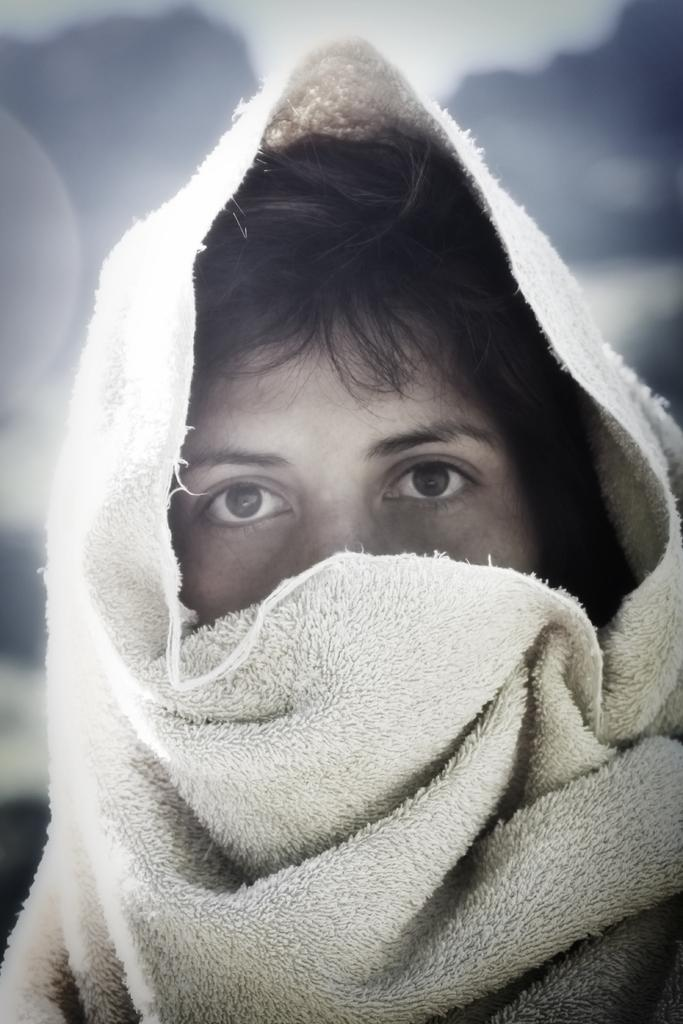What is the main subject of the image? There is a person in the image. What is the person wearing on their head? The person is wearing a cloth on their head. What color is the cloth? The cloth is white in color. How would you describe the background of the image? The background of the image is blurred. How many dogs are sitting on the pan in the image? There are no dogs or pans present in the image. 